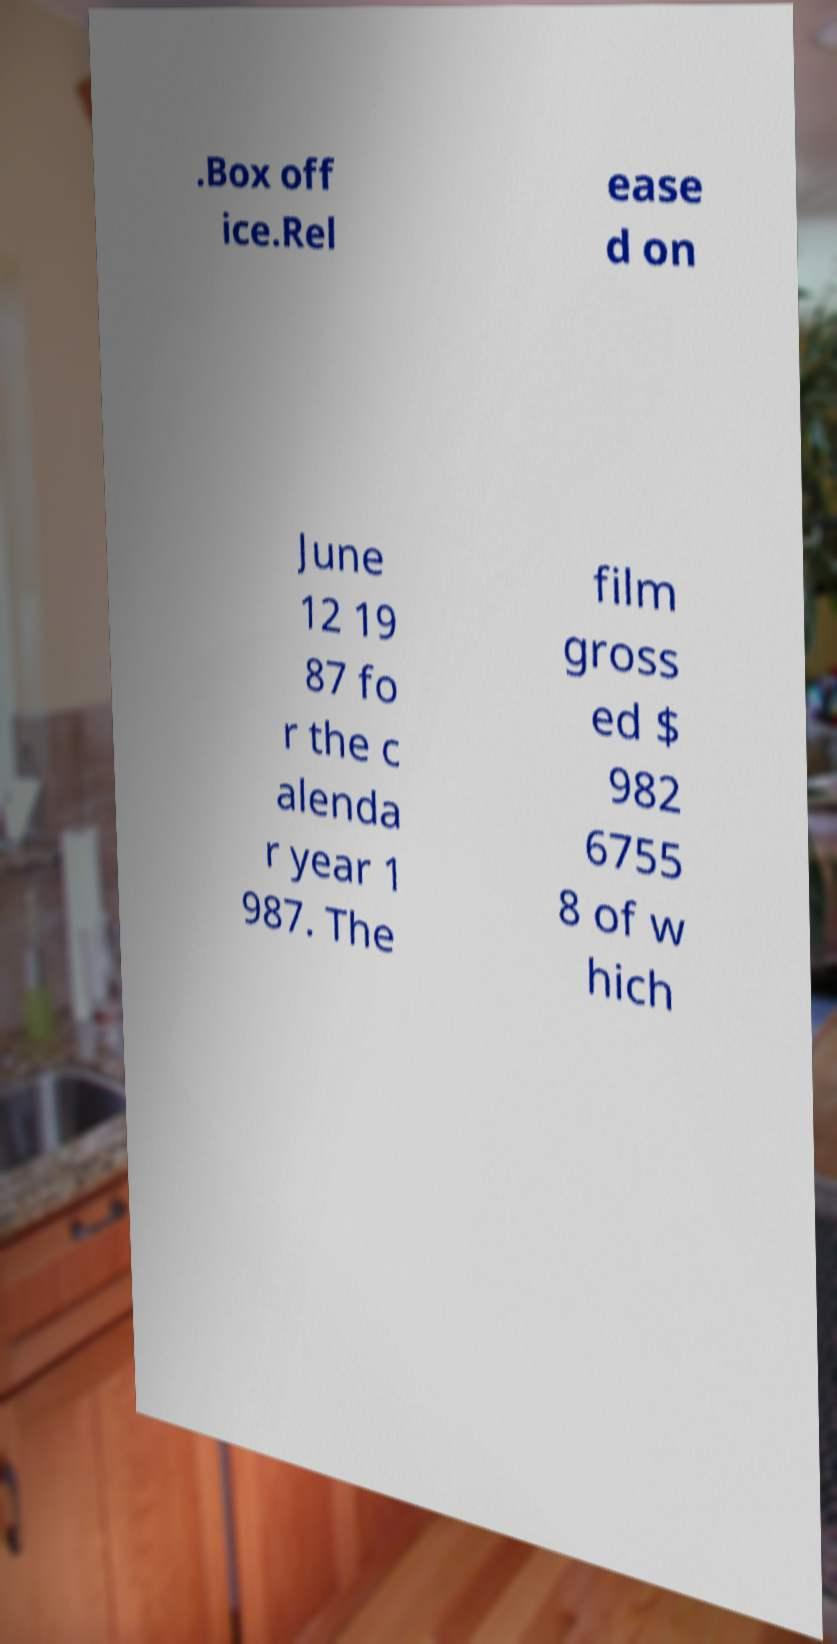Please identify and transcribe the text found in this image. .Box off ice.Rel ease d on June 12 19 87 fo r the c alenda r year 1 987. The film gross ed $ 982 6755 8 of w hich 